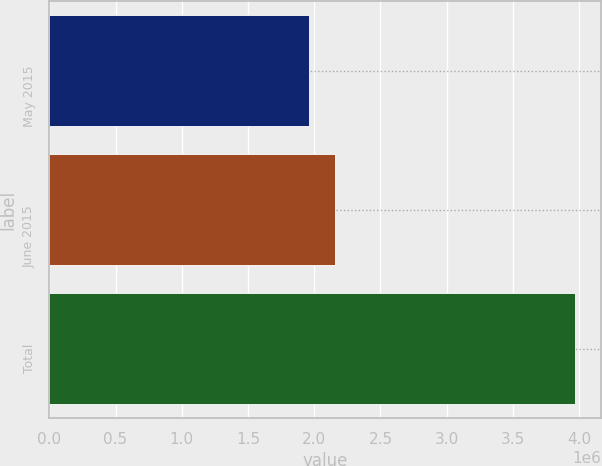Convert chart to OTSL. <chart><loc_0><loc_0><loc_500><loc_500><bar_chart><fcel>May 2015<fcel>June 2015<fcel>Total<nl><fcel>1.95956e+06<fcel>2.16021e+06<fcel>3.96602e+06<nl></chart> 